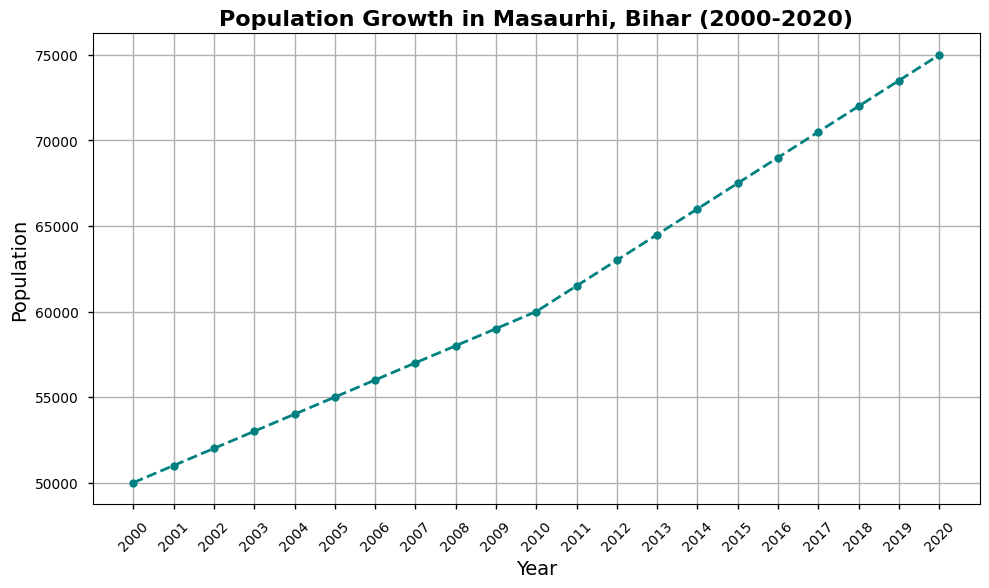What is the population of Masaurhi, Bihar in the year 2010? Look at the data point corresponding to the year 2010 on the line chart. The population is 60,000.
Answer: 60,000 In which year did the population first reach 70,000? Observe the data points and identify the first year where the population reaches or surpasses 70,000. This happens in 2017.
Answer: 2017 What is the difference in population between the year 2000 and the year 2020? Subtract the population in 2000 from the population in 2020: 75,000 - 50,000 = 25,000.
Answer: 25,000 How much did the population grow from 2003 to 2008? Subtract the population in 2003 from the population in 2008: 58,000 - 53,000 = 5,000.
Answer: 5,000 What is the average annual population growth rate between 2000 and 2020? To find the average annual growth rate, divide the total population increase by the number of years: (75,000 - 50,000) / (2020 - 2000) = 25,000 / 20 = 1,250
Answer: 1,250 Were there any years where the population did not increase compared to the previous year? Examine the slopes of the line for any flat sections. There are no years where the population did not increase.
Answer: No What is the median population value from 2000 to 2020? Arrange the populations in ascending order and find the middle value. Since there are 21 data points, the median is the 11th value: 60,000.
Answer: 60,000 By how much did the population increase from 2010 to 2011? Subtract the population in 2010 from the population in 2011: 61,500 - 60,000 = 1,500.
Answer: 1,500 Which year saw the highest increase in population compared to the previous year? Compare the population increase between each consecutive year and find the maximum one. From 2010 to 2011, the increase is 1,500, which is the highest.
Answer: 2010-2011 Did the population growth rate accelerate or decelerate after 2010 compared to before 2010? Compare the slope of the line before and after 2010. The growth rate after 2010 appears steeper, indicating an acceleration.
Answer: Accelerate 